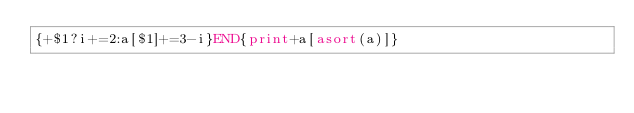Convert code to text. <code><loc_0><loc_0><loc_500><loc_500><_Awk_>{+$1?i+=2:a[$1]+=3-i}END{print+a[asort(a)]}</code> 